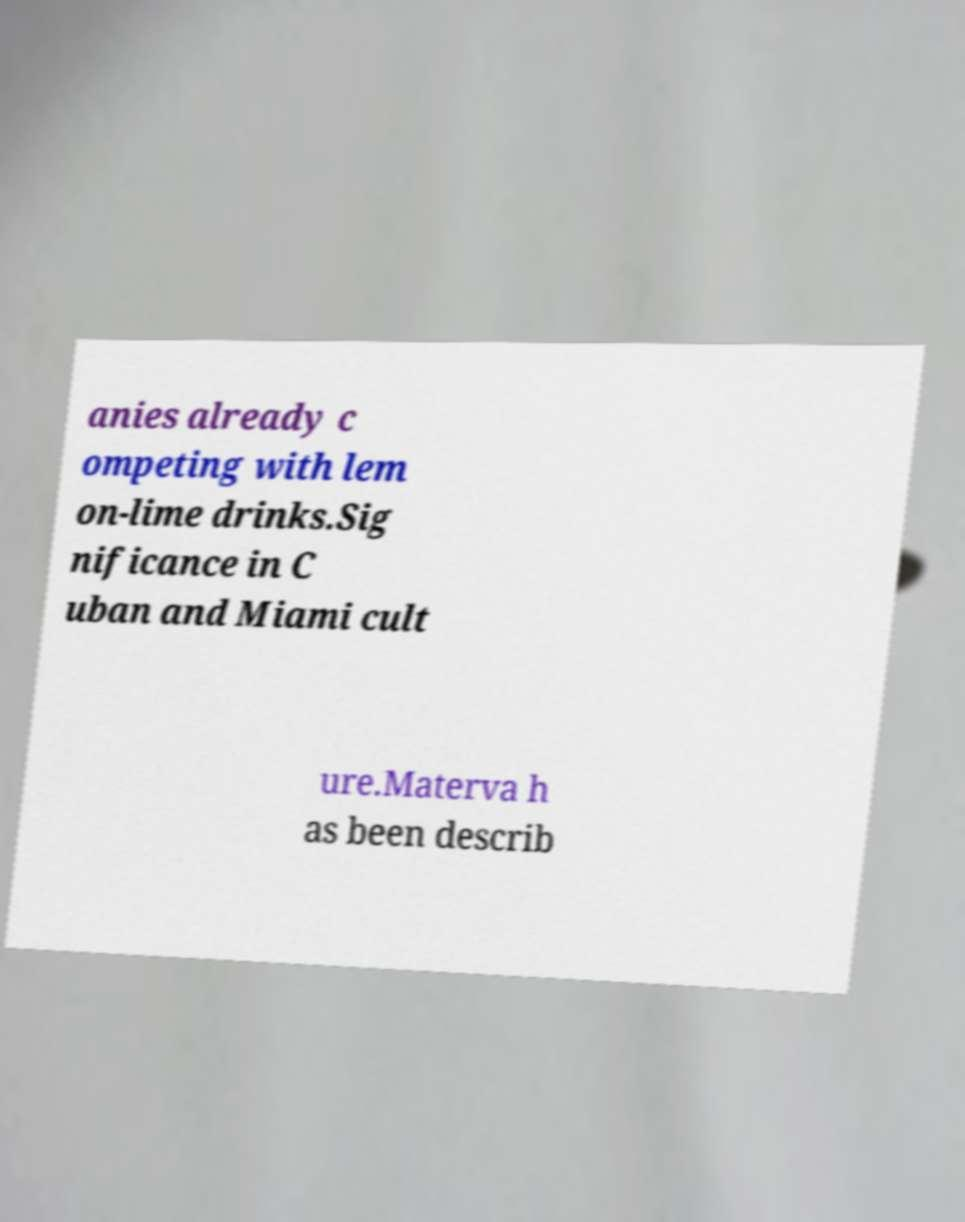Can you accurately transcribe the text from the provided image for me? anies already c ompeting with lem on-lime drinks.Sig nificance in C uban and Miami cult ure.Materva h as been describ 